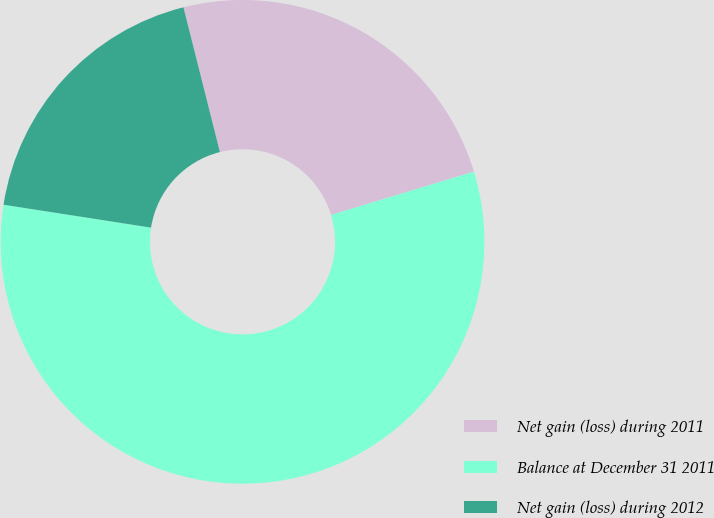<chart> <loc_0><loc_0><loc_500><loc_500><pie_chart><fcel>Net gain (loss) during 2011<fcel>Balance at December 31 2011<fcel>Net gain (loss) during 2012<nl><fcel>24.24%<fcel>57.14%<fcel>18.62%<nl></chart> 